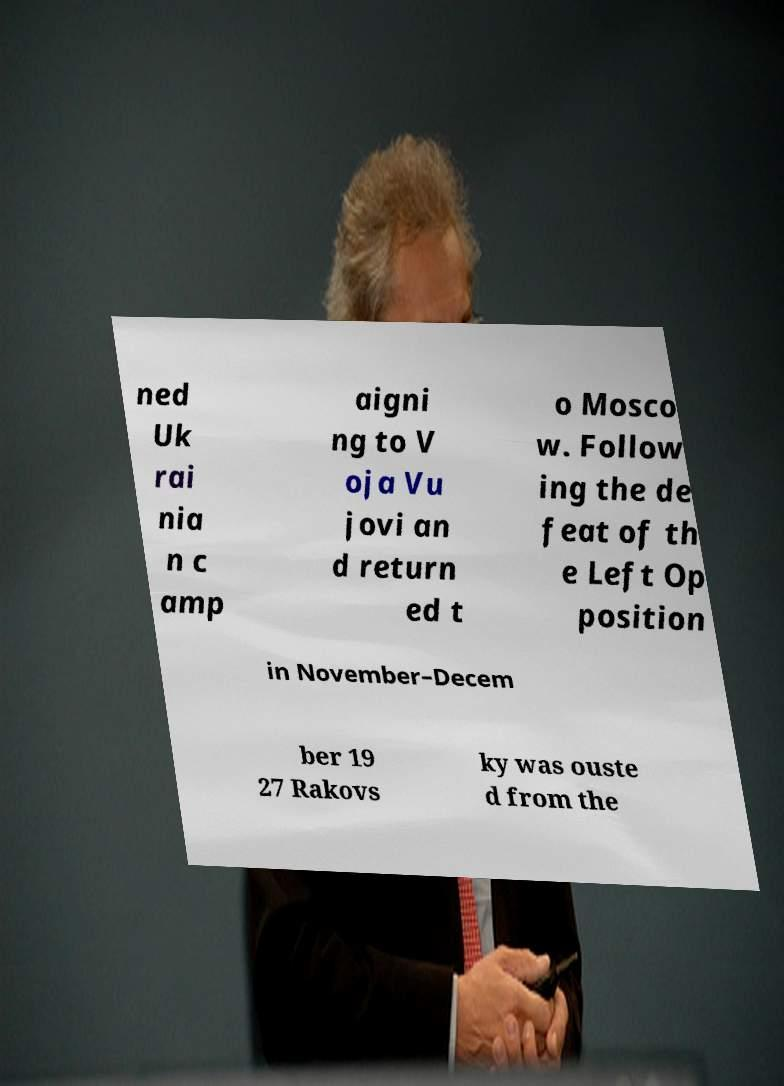I need the written content from this picture converted into text. Can you do that? ned Uk rai nia n c amp aigni ng to V oja Vu jovi an d return ed t o Mosco w. Follow ing the de feat of th e Left Op position in November–Decem ber 19 27 Rakovs ky was ouste d from the 